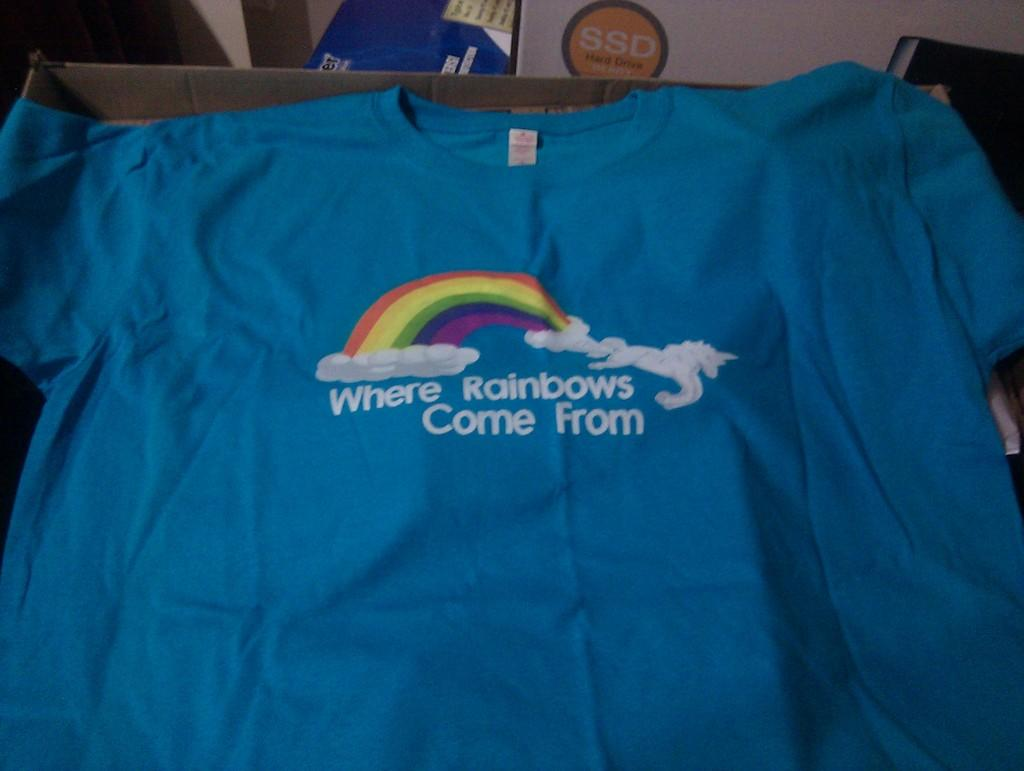<image>
Create a compact narrative representing the image presented. a teal shirt with white writing stating where rainbows come from 